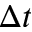Convert formula to latex. <formula><loc_0><loc_0><loc_500><loc_500>\Delta t</formula> 